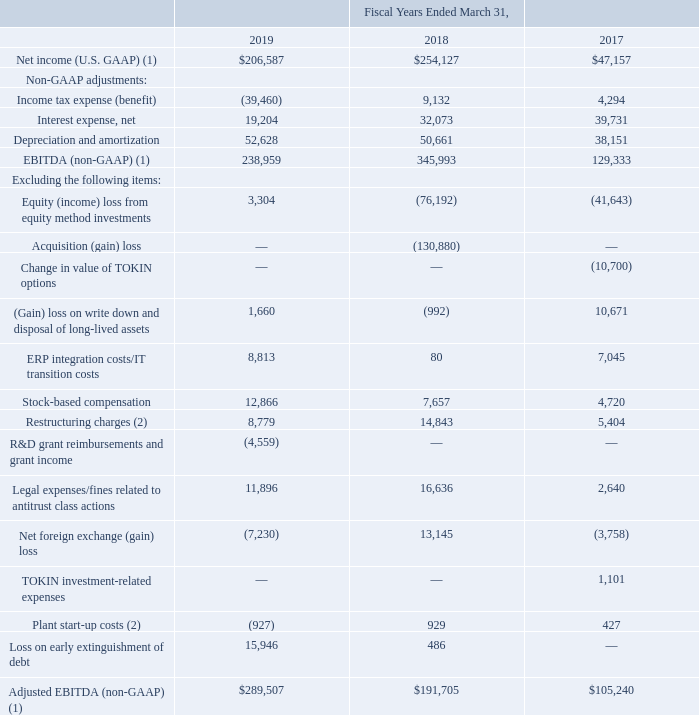The following table provides reconciliation from U.S. GAAP Net income to non-GAAP Adjusted EBITDA (amounts in thousands):
(1) Fiscal years ending March 31, 2018 and 2017 adjusted due to the adoption of ASC 606.
(2) $0.9 million in costs incurred during fiscal year 2018 related to the relocation of the Company's tantalum powder facility equipment from Carson City, Nevada to its existing Matamoros, Mexico plant were reclassified from “Plant start-up costs” to “Restructuring charges” during fiscal year 2019.
What was the net interest expense in 2019?
Answer scale should be: thousand. 19,204. What was the depreciation and amortization in 2017?
Answer scale should be: thousand. 38,151. Which years does the table provide information for the reconciliation from U.S. GAAP Net income to non-GAAP Adjusted EBITDA? 2019, 2018, 2017. What was the change in the Net foreign exchange (gain) loss between 2017 and 2018?
Answer scale should be: thousand. 13,145-(-3,758)
Answer: 16903. What was the change in the Loss on early extinguishment of debt between 2018 and 2019?
Answer scale should be: thousand. 15,946-486
Answer: 15460. What was the percentage change in the net interest expense between 2018 and 2019?
Answer scale should be: percent. (19,204-32,073)/32,073
Answer: -40.12. 